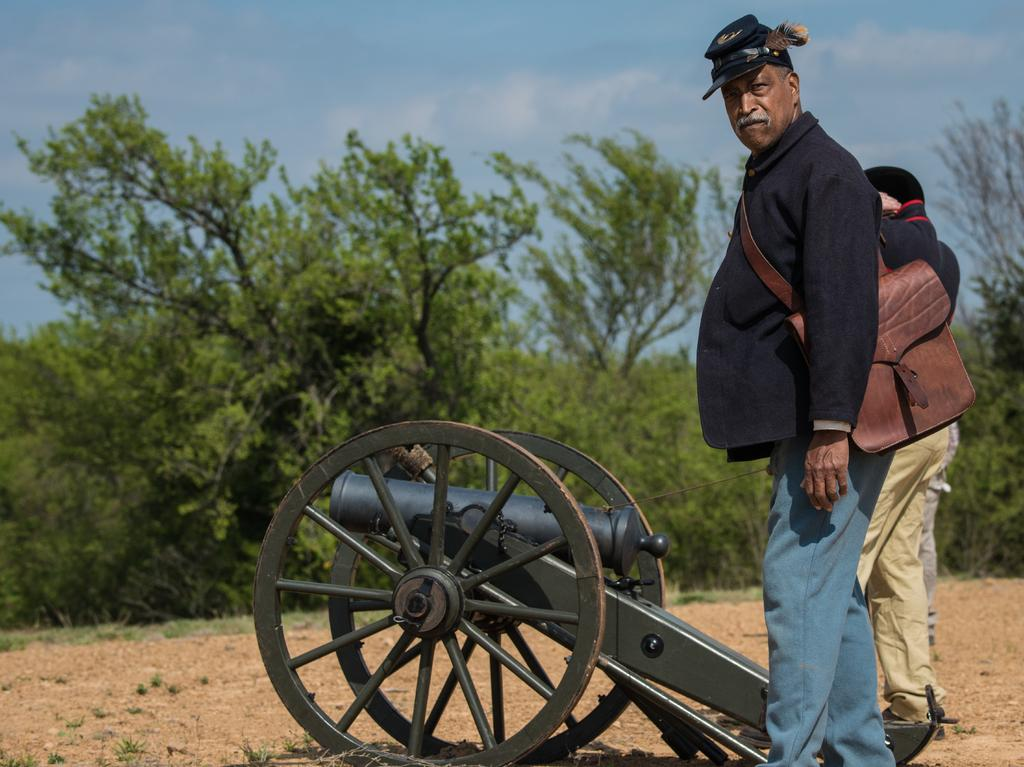What are the people in the image standing in front of? The people in the image are standing in front of a cannon. Can you describe any specific clothing or accessories worn by the people? One person is wearing a brown color bag. What can be seen in the background of the image? There are many trees and the sky visible in the background. What is the price of the jewel worn by the person in the image? There is no jewel visible in the image, so it is not possible to determine its price. 